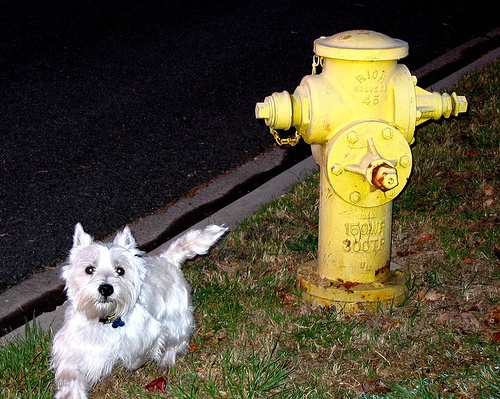Describe the objects in this image and their specific colors. I can see fire hydrant in black, khaki, tan, and olive tones and dog in black, lavender, darkgray, and gray tones in this image. 